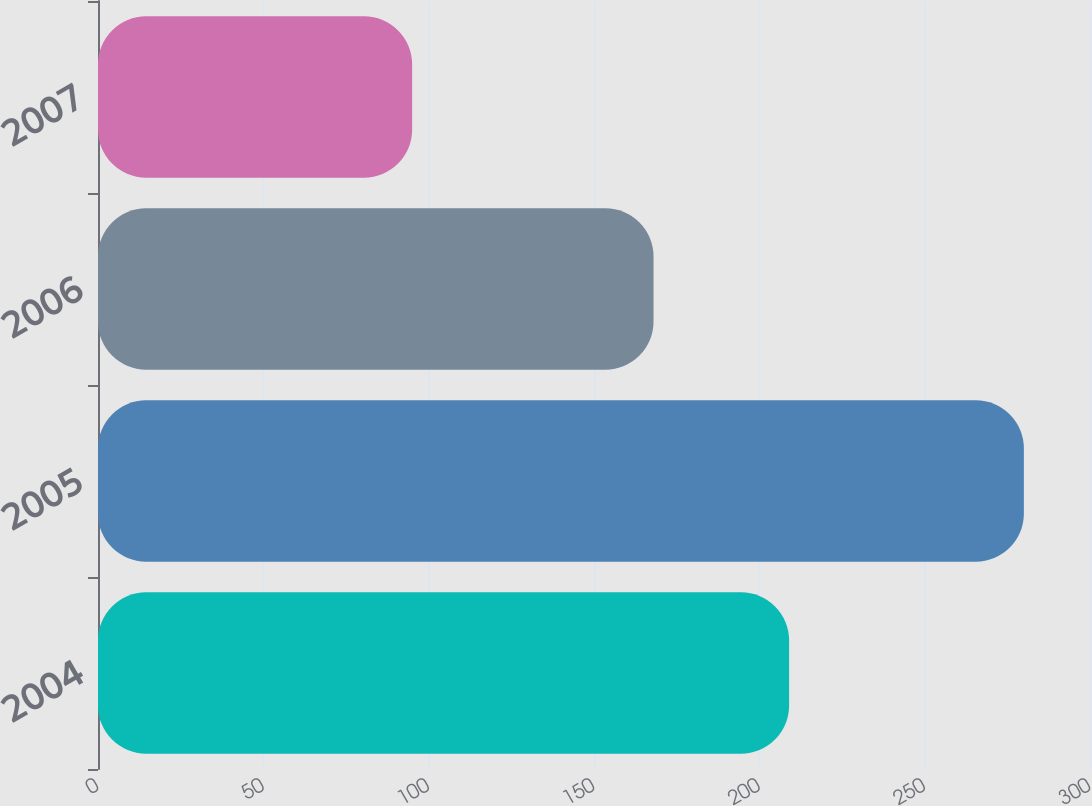Convert chart to OTSL. <chart><loc_0><loc_0><loc_500><loc_500><bar_chart><fcel>2004<fcel>2005<fcel>2006<fcel>2007<nl><fcel>209<fcel>280<fcel>168<fcel>95<nl></chart> 